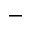Convert formula to latex. <formula><loc_0><loc_0><loc_500><loc_500>-</formula> 